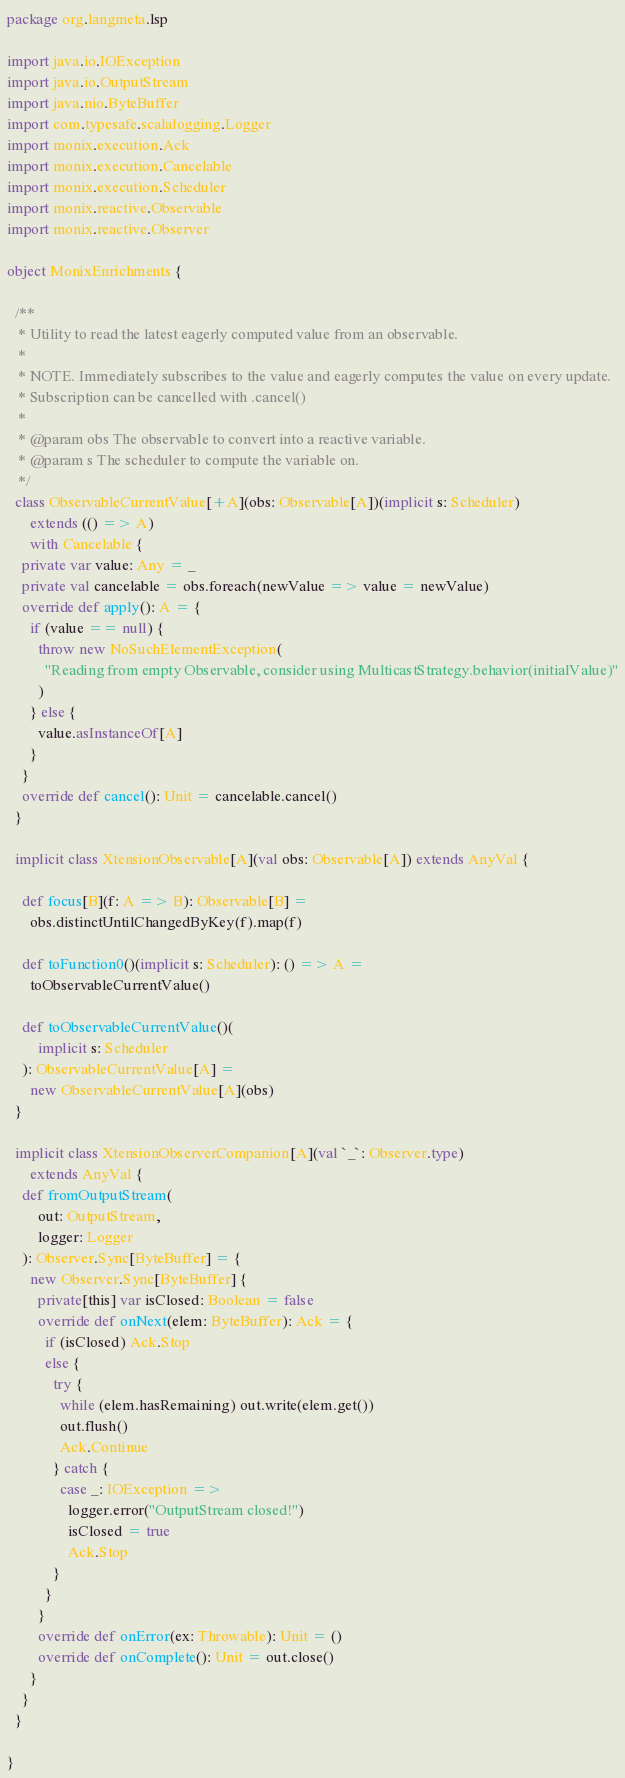Convert code to text. <code><loc_0><loc_0><loc_500><loc_500><_Scala_>package org.langmeta.lsp

import java.io.IOException
import java.io.OutputStream
import java.nio.ByteBuffer
import com.typesafe.scalalogging.Logger
import monix.execution.Ack
import monix.execution.Cancelable
import monix.execution.Scheduler
import monix.reactive.Observable
import monix.reactive.Observer

object MonixEnrichments {

  /**
   * Utility to read the latest eagerly computed value from an observable.
   *
   * NOTE. Immediately subscribes to the value and eagerly computes the value on every update.
   * Subscription can be cancelled with .cancel()
   *
   * @param obs The observable to convert into a reactive variable.
   * @param s The scheduler to compute the variable on.
   */
  class ObservableCurrentValue[+A](obs: Observable[A])(implicit s: Scheduler)
      extends (() => A)
      with Cancelable {
    private var value: Any = _
    private val cancelable = obs.foreach(newValue => value = newValue)
    override def apply(): A = {
      if (value == null) {
        throw new NoSuchElementException(
          "Reading from empty Observable, consider using MulticastStrategy.behavior(initialValue)"
        )
      } else {
        value.asInstanceOf[A]
      }
    }
    override def cancel(): Unit = cancelable.cancel()
  }

  implicit class XtensionObservable[A](val obs: Observable[A]) extends AnyVal {

    def focus[B](f: A => B): Observable[B] =
      obs.distinctUntilChangedByKey(f).map(f)

    def toFunction0()(implicit s: Scheduler): () => A =
      toObservableCurrentValue()

    def toObservableCurrentValue()(
        implicit s: Scheduler
    ): ObservableCurrentValue[A] =
      new ObservableCurrentValue[A](obs)
  }

  implicit class XtensionObserverCompanion[A](val `_`: Observer.type)
      extends AnyVal {
    def fromOutputStream(
        out: OutputStream,
        logger: Logger
    ): Observer.Sync[ByteBuffer] = {
      new Observer.Sync[ByteBuffer] {
        private[this] var isClosed: Boolean = false
        override def onNext(elem: ByteBuffer): Ack = {
          if (isClosed) Ack.Stop
          else {
            try {
              while (elem.hasRemaining) out.write(elem.get())
              out.flush()
              Ack.Continue
            } catch {
              case _: IOException =>
                logger.error("OutputStream closed!")
                isClosed = true
                Ack.Stop
            }
          }
        }
        override def onError(ex: Throwable): Unit = ()
        override def onComplete(): Unit = out.close()
      }
    }
  }

}
</code> 